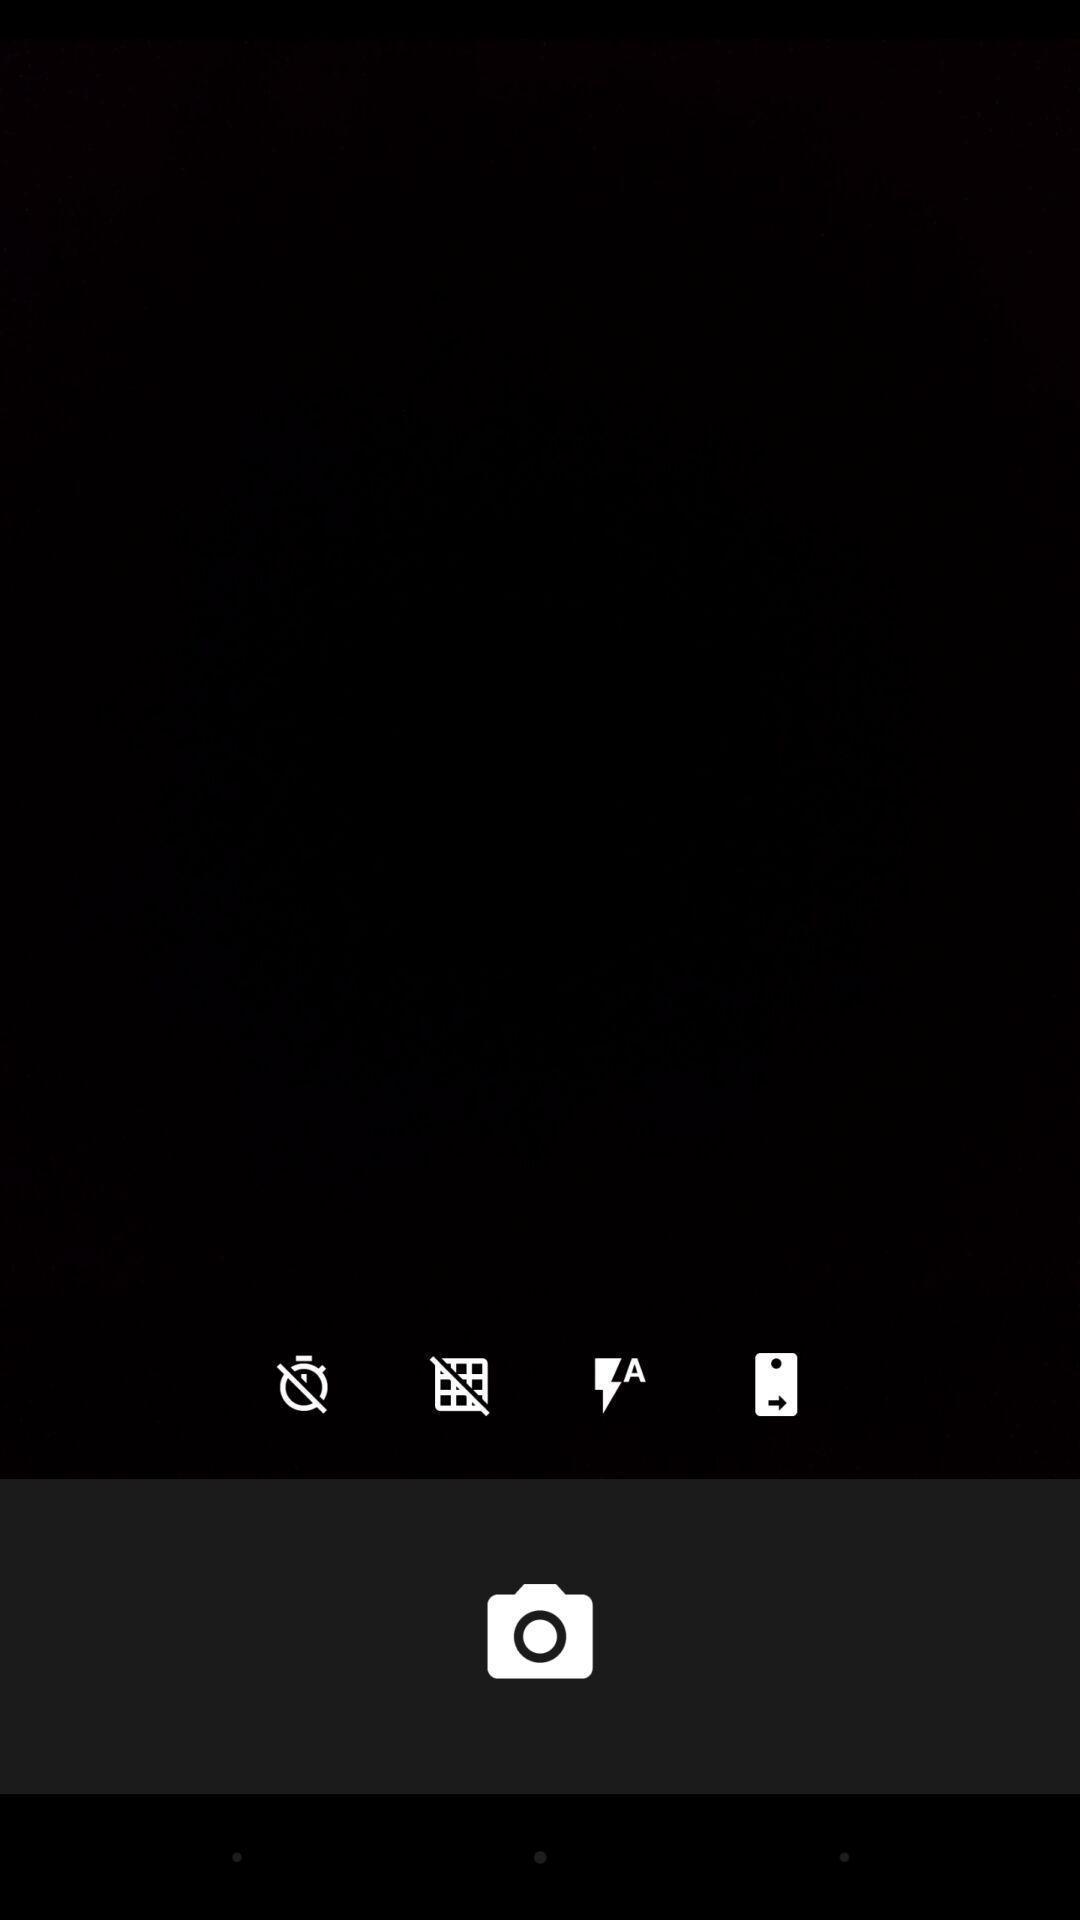Tell me what you see in this picture. Window displaying the camera page. 